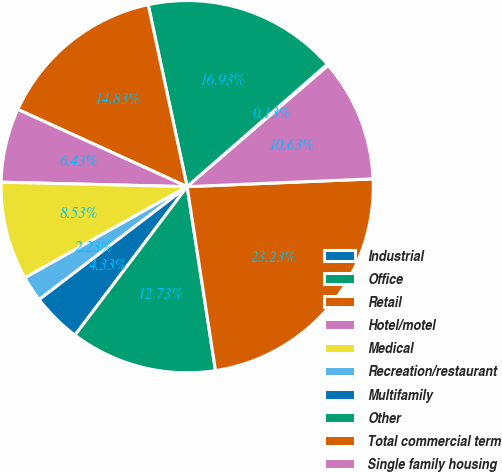Convert chart to OTSL. <chart><loc_0><loc_0><loc_500><loc_500><pie_chart><fcel>Industrial<fcel>Office<fcel>Retail<fcel>Hotel/motel<fcel>Medical<fcel>Recreation/restaurant<fcel>Multifamily<fcel>Other<fcel>Total commercial term<fcel>Single family housing<nl><fcel>0.13%<fcel>16.93%<fcel>14.83%<fcel>6.43%<fcel>8.53%<fcel>2.23%<fcel>4.33%<fcel>12.73%<fcel>23.23%<fcel>10.63%<nl></chart> 